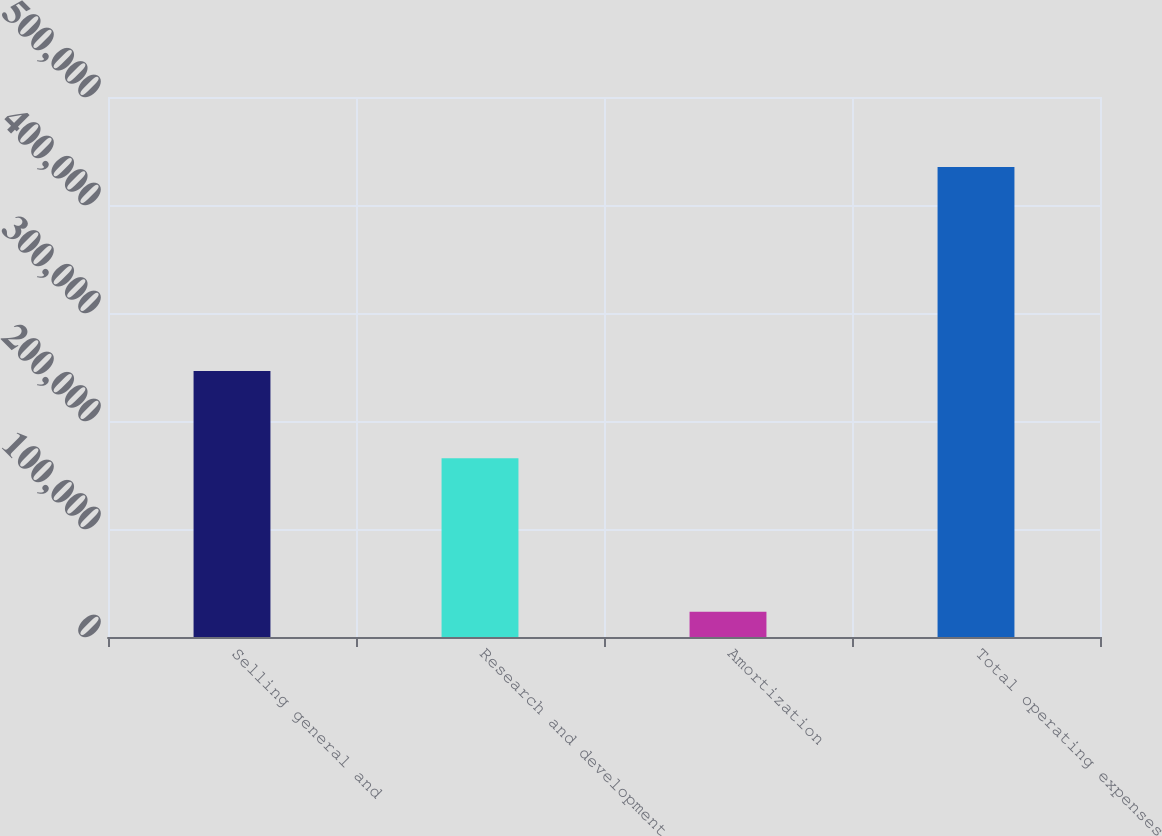Convert chart to OTSL. <chart><loc_0><loc_0><loc_500><loc_500><bar_chart><fcel>Selling general and<fcel>Research and development<fcel>Amortization<fcel>Total operating expenses<nl><fcel>246376<fcel>165421<fcel>23388<fcel>435185<nl></chart> 